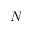<formula> <loc_0><loc_0><loc_500><loc_500>N</formula> 